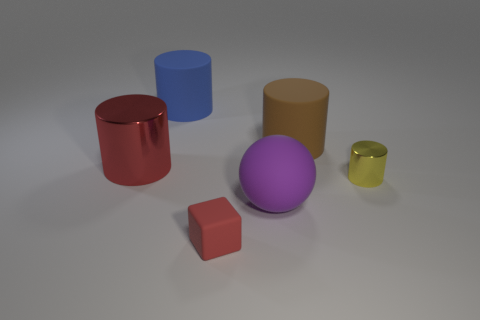There is a large object that is the same color as the small rubber thing; what material is it?
Provide a succinct answer. Metal. The shiny thing that is the same color as the tiny rubber cube is what size?
Offer a very short reply. Large. Is the number of small red blocks less than the number of cylinders?
Your response must be concise. Yes. Is the color of the metal cylinder on the left side of the big purple matte ball the same as the small block?
Provide a short and direct response. Yes. The big cylinder that is right of the red object in front of the metal cylinder that is behind the yellow cylinder is made of what material?
Your answer should be compact. Rubber. Are there any tiny blocks of the same color as the large metal thing?
Give a very brief answer. Yes. Is the number of small yellow metal cylinders that are behind the tiny red block less than the number of metallic objects?
Ensure brevity in your answer.  Yes. Do the matte object on the left side of the red matte cube and the big red metallic cylinder have the same size?
Offer a very short reply. Yes. How many big objects are both behind the large ball and right of the big metal cylinder?
Provide a succinct answer. 2. How big is the yellow thing right of the large matte cylinder that is to the right of the red rubber block?
Ensure brevity in your answer.  Small. 